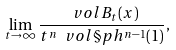<formula> <loc_0><loc_0><loc_500><loc_500>\lim _ { t \to \infty } \frac { \ v o l B _ { t } ( x ) } { t ^ { n } \ v o l \S p h ^ { n - 1 } ( 1 ) } ,</formula> 